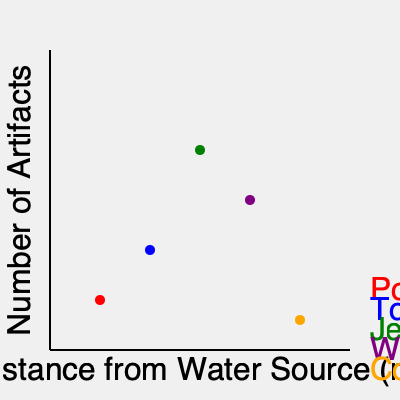Based on the distribution of artifact types across the mapped archaeological site, which category of artifacts appears to be most closely associated with the water source, and what might this suggest about the site's inhabitants? To answer this question, we need to analyze the graph step-by-step:

1. The x-axis represents the distance from the water source, with closer distances to the left.
2. The y-axis represents the number of artifacts found.
3. Each colored dot represents a different artifact category:
   - Red: Pottery
   - Blue: Tools
   - Green: Jewelry
   - Purple: Weapons
   - Orange: Coins

4. Observing the position of each dot:
   - Pottery (red) is closest to the water source.
   - Tools (blue) are the second closest.
   - Jewelry (green) is furthest from the water source but highest in quantity.
   - Weapons (purple) are in the middle range.
   - Coins (orange) are second furthest but lowest in quantity.

5. Pottery being closest to the water source suggests it was most frequently used near water.

6. This distribution implies that the site's inhabitants likely:
   - Used pottery for water collection and storage.
   - Engaged in activities requiring water near the source (e.g., cooking, cleaning).
   - May have had a settlement area close to the water.

7. The high concentration of jewelry further from the water might indicate:
   - A residential or trading area away from the water source.
   - Possible social stratification or specialized craft production.

In conclusion, pottery appears most closely associated with the water source, suggesting the inhabitants heavily relied on water-related activities and likely had a significant portion of their daily life centered around the water source.
Answer: Pottery; indicates water-centric activities and settlement near the water source. 